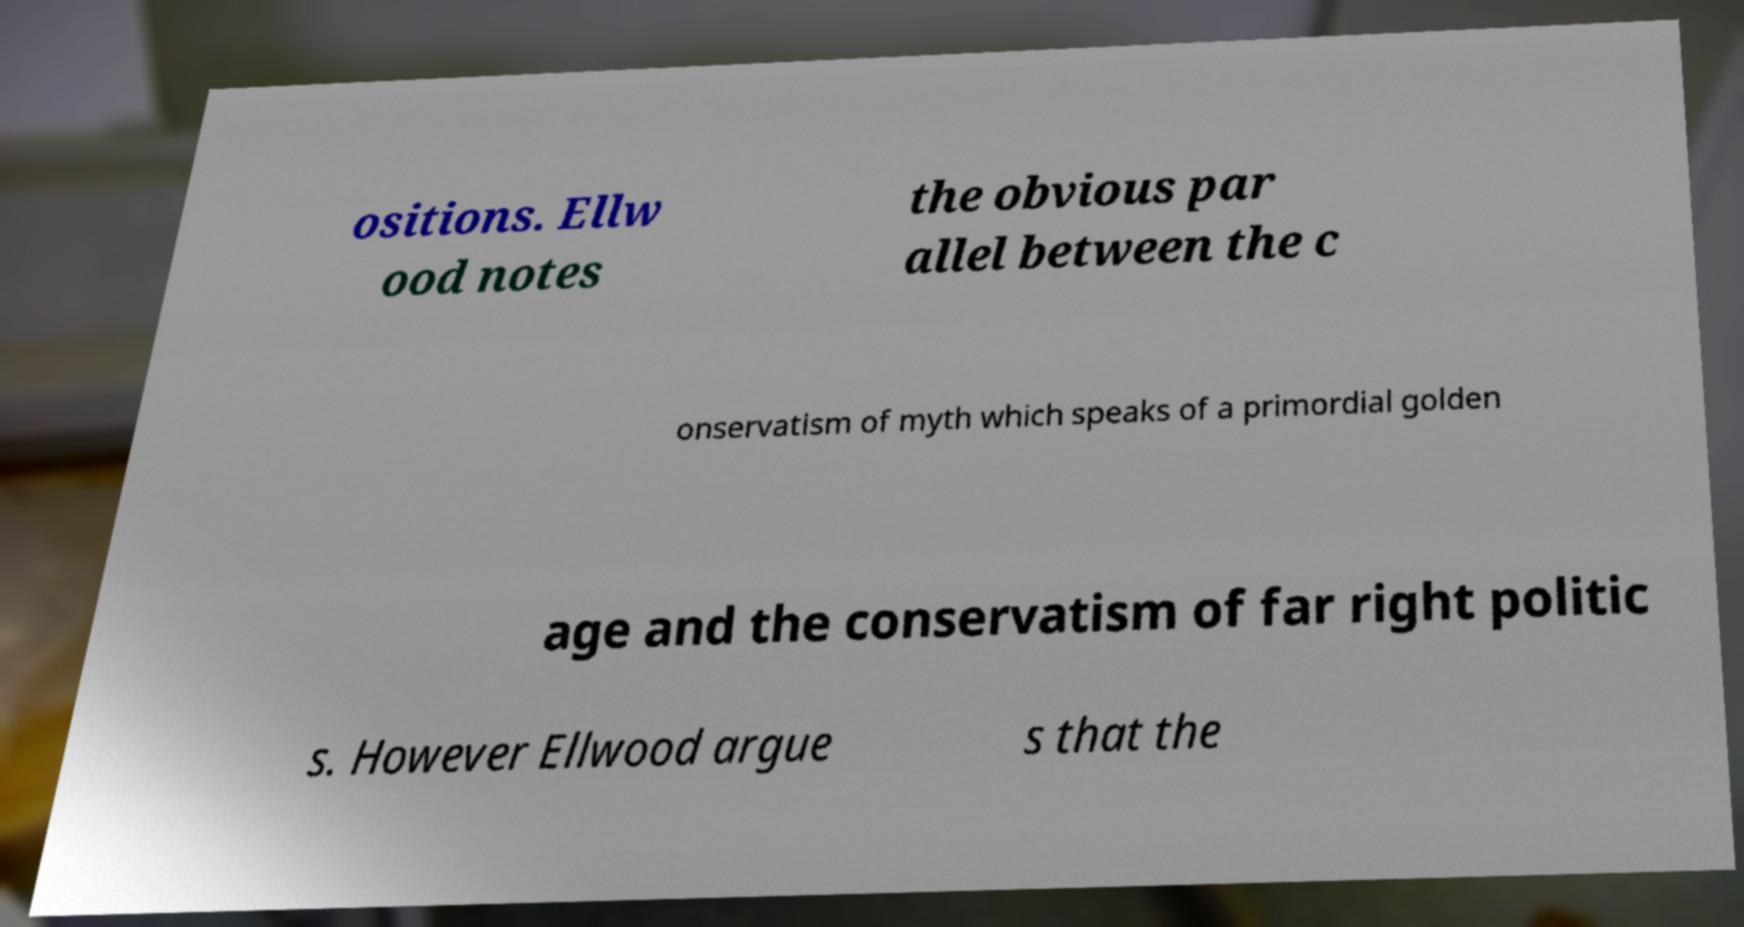Can you read and provide the text displayed in the image?This photo seems to have some interesting text. Can you extract and type it out for me? ositions. Ellw ood notes the obvious par allel between the c onservatism of myth which speaks of a primordial golden age and the conservatism of far right politic s. However Ellwood argue s that the 